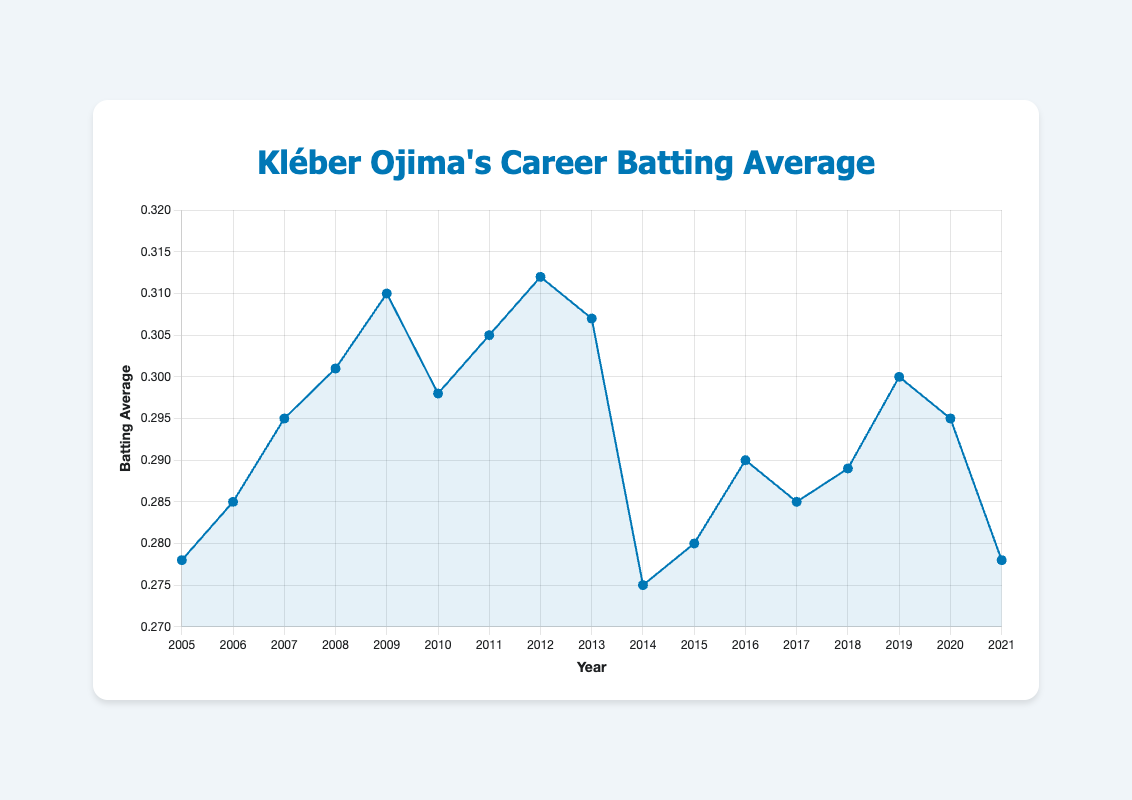What was Kléber Ojima's batting average in 2008? Look at the year 2008 on the x-axis and find the corresponding point on the line. The y-coordinate of the point is his batting average for that year, which is 0.301.
Answer: 0.301 In which year did Kléber Ojima achieve his highest batting average, and what was it? Scan the y-axis to find the highest point on the line. Identify the year directly below this point on the x-axis, which is 2012, and the corresponding y-coordinate which indicates the highest batting average, 0.312.
Answer: 2012, 0.312 How did Kléber Ojima's batting average change when he switched from the Tokyo Giants to the Osaka BlueWave? Identify the years he played for Tokyo Giants (2005-2008) and Osaka BlueWave (2009 onwards). Compare the batting average value in the last year with Tokyo Giants (2008, 0.301) to the first year with Osaka BlueWave (2009, 0.310). Calculate the difference: 0.310 - 0.301 = 0.009.
Answer: Increased by 0.009 Which team did Kléber Ojima play for when his batting average was the lowest, and what was that average? Find the lowest point on the line and identify the year directly below it on the x-axis, which is 2014. Look at the label for this year to find the team (Hokkaido Fighters) and the corresponding batting average, 0.275.
Answer: Hokkaido Fighters, 0.275 What was the average batting average across Kléber Ojima's career? Sum all the batting averages from 2005 to 2021: (0.278 + 0.285 + 0.295 + 0.301 + 0.310 + 0.298 + 0.305 + 0.312 + 0.307 + 0.275 + 0.280 + 0.290 + 0.285 + 0.289 + 0.300 + 0.295 + 0.278) and divide by the number of years (17). This gives (5.693/17), resulting in approximately 0.335
Answer: 0.335 Which year saw the sharpest drop in Kléber Ojima’s batting average and what was the numerical change? Check the differences between consecutive years' batting averages and find the largest drop. The biggest decrease occurred between 2013 (0.307) and 2014 (0.275), with a drop of 0.307 - 0.275 = 0.032.
Answer: 2014, 0.032 Compare Kléber Ojima's batting average in his final year with Fukuoka Hawks to his first year with Seibu Lions. Locate the final year of playing for Fukuoka Hawks (2020, 0.295) and compare it to the first year with Seibu Lions (2021, 0.278). Calculate the difference: 0.295 - 0.278 = 0.017.
Answer: Fukuoka Hawks higher by 0.017 During which season did Kléber Ojima play for the most teams and how many teams did he play for? Observe the data labels and count the number of distinct teams listed. He played for the same team for several consecutive seasons, so the number of teams is 4 (Tokyo Giants, Osaka BlueWave, Hokkaido Fighters, Fukuoka Hawks, and Seibu Lions).
Answer: 5 teams Was Kléber Ojima's overall trend in batting average increasing or decreasing over his career? Observe the general direction of the line from 2005 to 2021. Despite fluctuations, a majority of years show an initial increase and subsequent overall decline.
Answer: Varying with an overall declining trend 